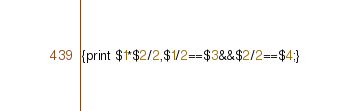Convert code to text. <code><loc_0><loc_0><loc_500><loc_500><_Awk_>{print $1*$2/2,$1/2==$3&&$2/2==$4;}</code> 